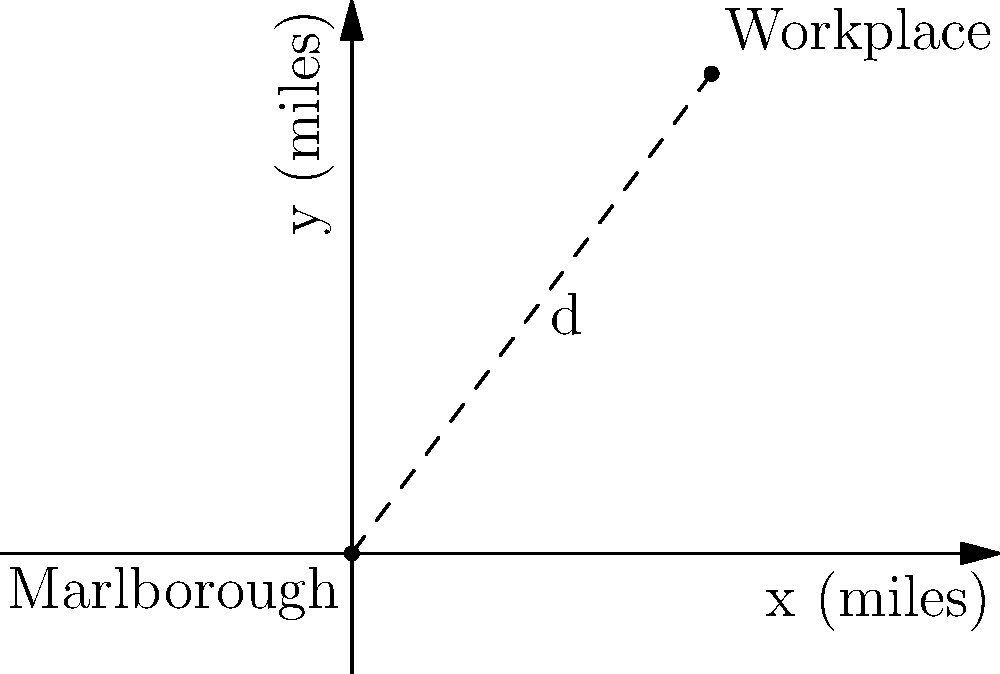Using the map provided, calculate the commute distance $d$ between Marlborough and Theresa M. Lee's workplace. The coordinates are given in miles, with Marlborough at $(0,0)$ and the workplace at $(60,80)$. Round your answer to the nearest whole mile. To calculate the commute distance between Marlborough and Theresa M. Lee's workplace, we can use the distance formula derived from the Pythagorean theorem:

$$d = \sqrt{(x_2 - x_1)^2 + (y_2 - y_1)^2}$$

Where:
$(x_1, y_1)$ are the coordinates of Marlborough $(0,0)$
$(x_2, y_2)$ are the coordinates of the workplace $(60,80)$

Let's plug these values into the formula:

$$d = \sqrt{(60 - 0)^2 + (80 - 0)^2}$$

Simplify:
$$d = \sqrt{60^2 + 80^2}$$

Calculate the squares:
$$d = \sqrt{3600 + 6400}$$

Add under the square root:
$$d = \sqrt{10000}$$

Take the square root:
$$d = 100$$

Therefore, the commute distance between Marlborough and Theresa M. Lee's workplace is 100 miles.
Answer: 100 miles 